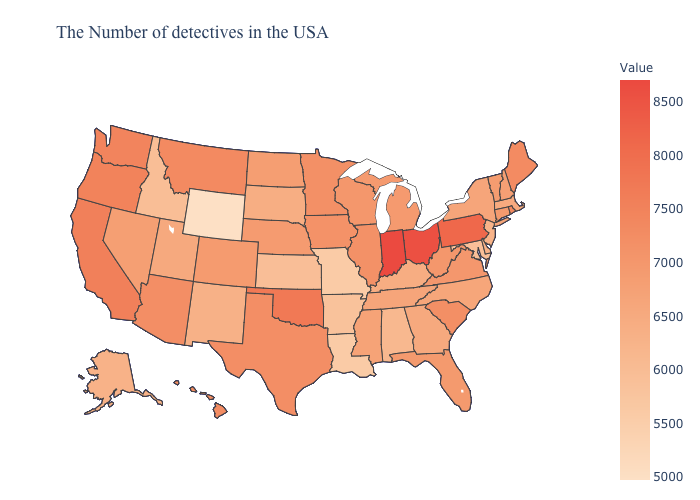Does Minnesota have the highest value in the USA?
Quick response, please. No. Which states hav the highest value in the Northeast?
Be succinct. Pennsylvania. Among the states that border Arizona , which have the lowest value?
Keep it brief. New Mexico. Which states have the highest value in the USA?
Concise answer only. Indiana. Which states have the lowest value in the USA?
Be succinct. Wyoming. Does North Carolina have the highest value in the USA?
Short answer required. No. Does Oregon have a lower value than Indiana?
Answer briefly. Yes. 